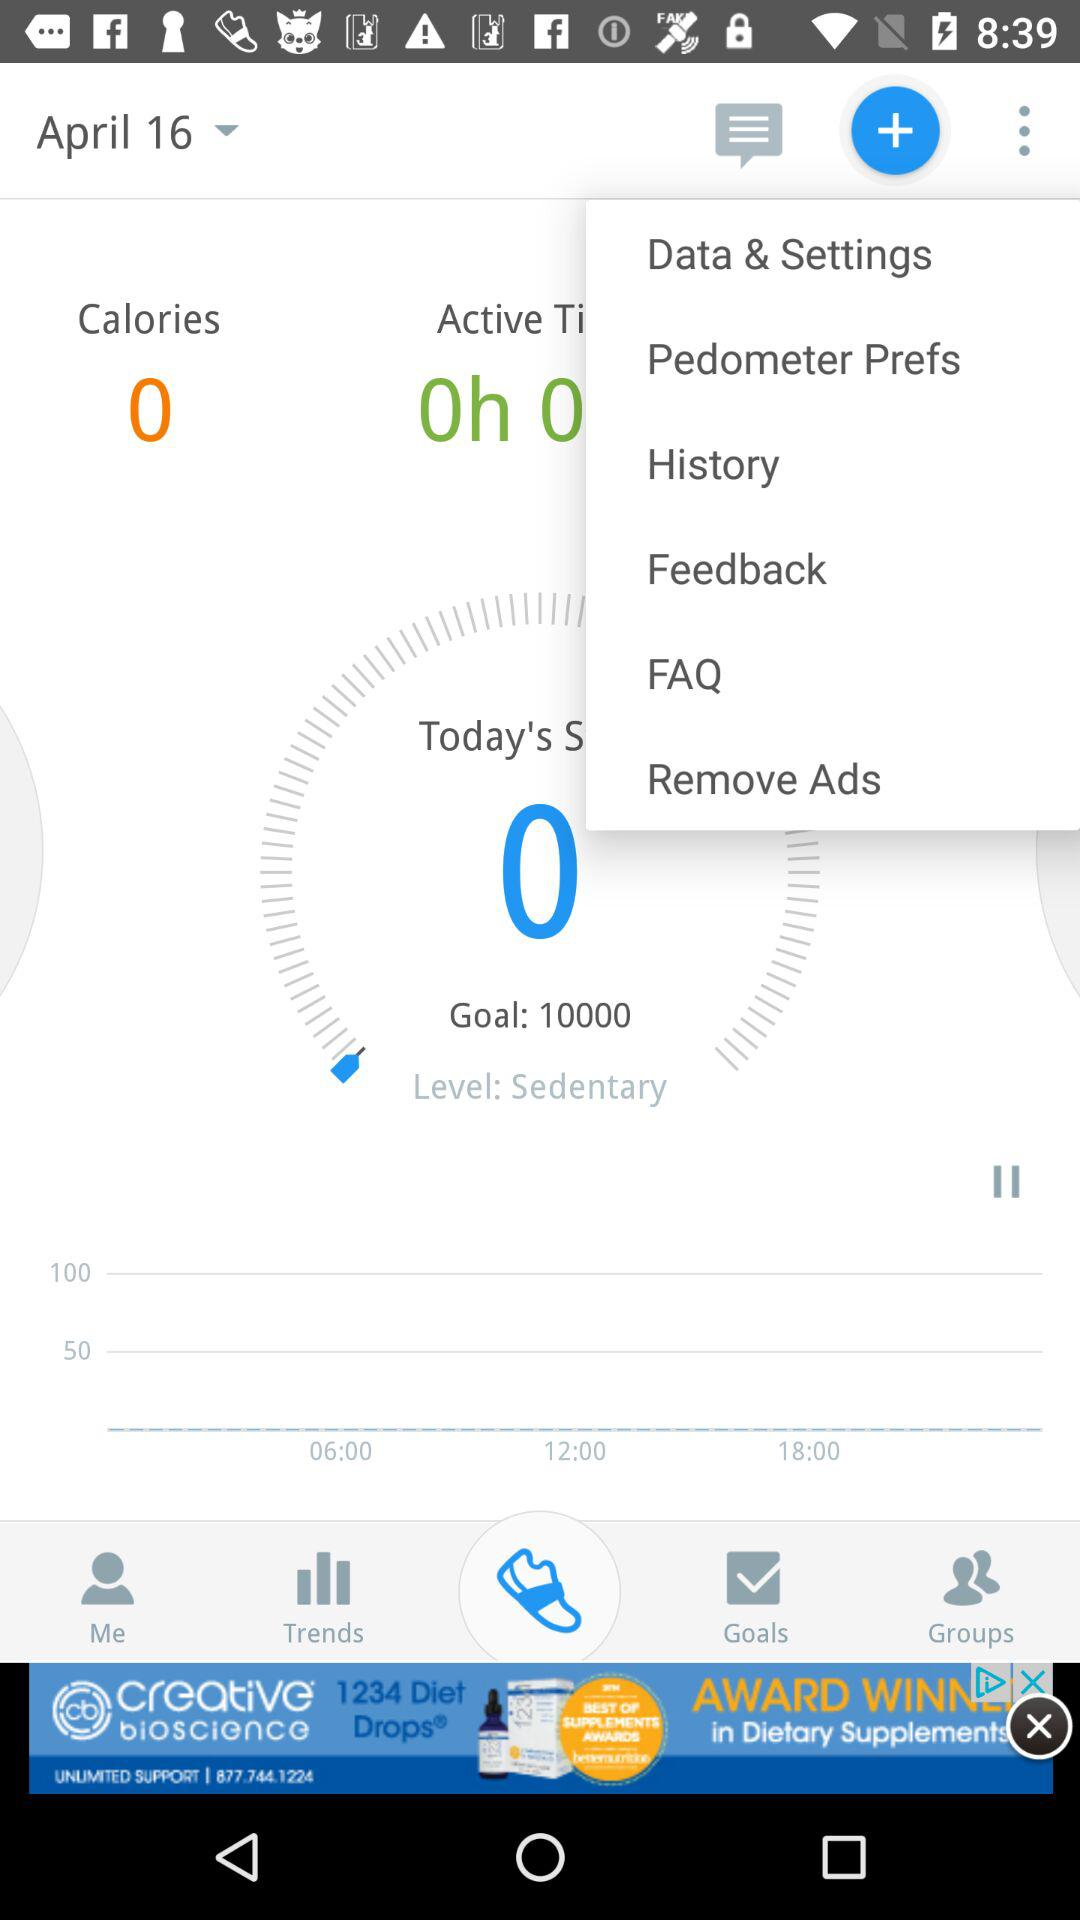What is the goal? The goal is to complete 10000 steps. 